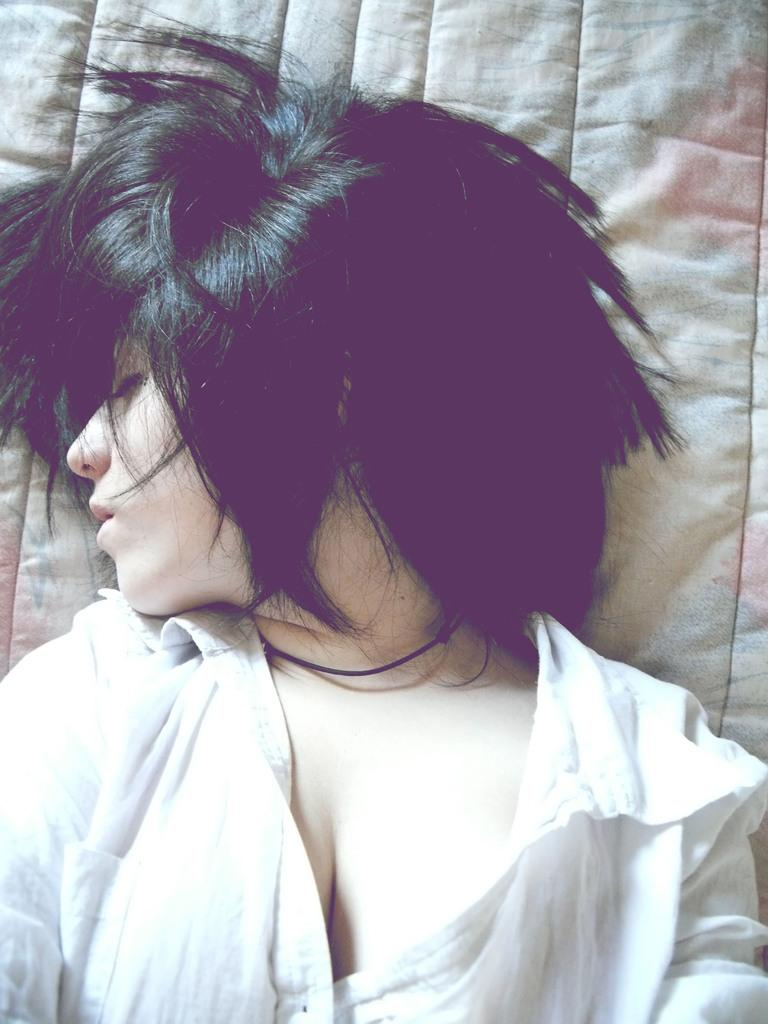Who is present in the image? There is a woman in the image. What is the woman doing in the image? The woman is lying on a bed. What type of lettuce can be seen on the woman's arm in the image? There is no lettuce present on the woman's arm in the image. 